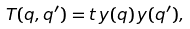Convert formula to latex. <formula><loc_0><loc_0><loc_500><loc_500>T ( q , q ^ { \prime } ) = t \, y ( q ) \, y ( q ^ { \prime } ) ,</formula> 